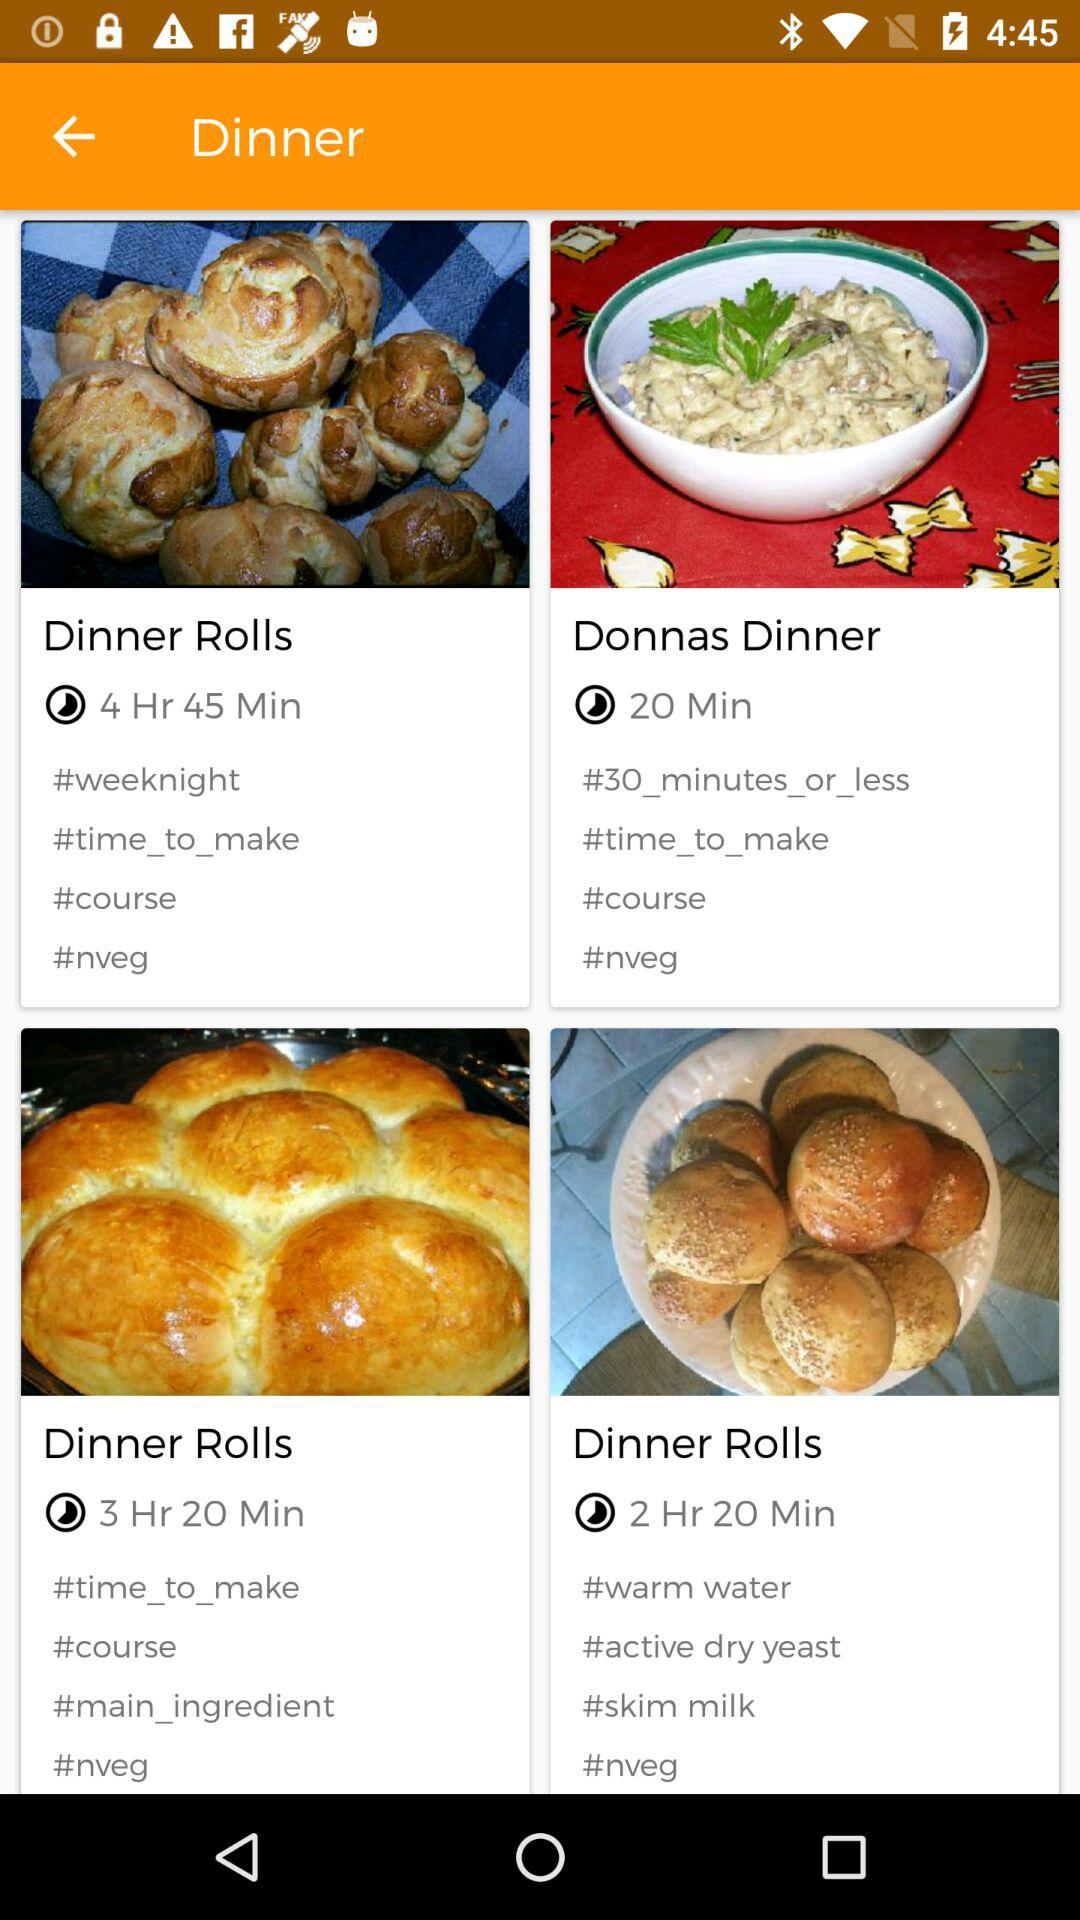How long will it take to make the "Donnas Dinner"? It will take 20 minutes to make the "Donnas Dinner". 